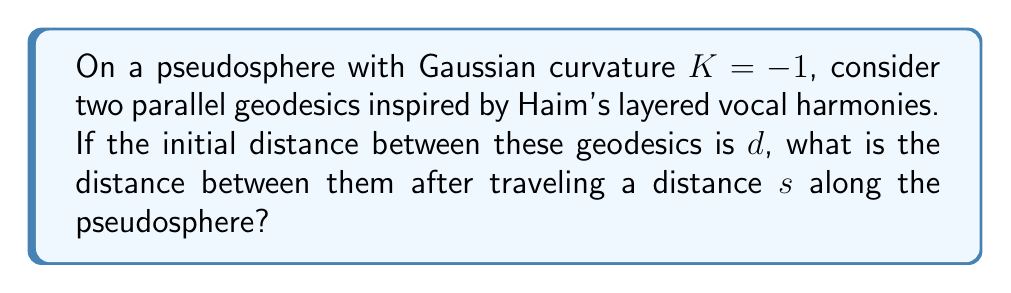Show me your answer to this math problem. Let's approach this step-by-step:

1) In Non-Euclidean geometry, specifically on a pseudosphere (a surface of constant negative curvature), parallel geodesics behave differently than in Euclidean geometry.

2) The formula for the distance between two parallel geodesics on a pseudosphere is given by:

   $$D(s) = d \cdot e^s$$

   Where:
   - $D(s)$ is the distance between the geodesics after traveling a distance $s$
   - $d$ is the initial distance between the geodesics
   - $e$ is the base of natural logarithms
   - $s$ is the distance traveled along the pseudosphere

3) This exponential relationship reflects the "spreading out" of parallel lines on a pseudosphere, similar to how Haim's vocal harmonies might start close together and then diverge into distinct layers.

4) To solve this problem, we simply need to plug in the given values into the formula.

5) Note that we don't need specific values for $d$ and $s$ to express the final answer, as the question asks for the general relationship.

[asy]
import geometry;

size(200);

path p1 = (0,0)--(100,50);
path p2 = (0,20)--(100,100);

draw(p1,blue);
draw(p2,blue);

label("$d$", (0,10), W);
label("$D(s)$", (100,75), E);
label("$s$", (50,-5), S);

draw((0,0)--(0,20),dashed);
draw((100,50)--(100,100),dashed);
[/asy]
Answer: $D(s) = d \cdot e^s$ 